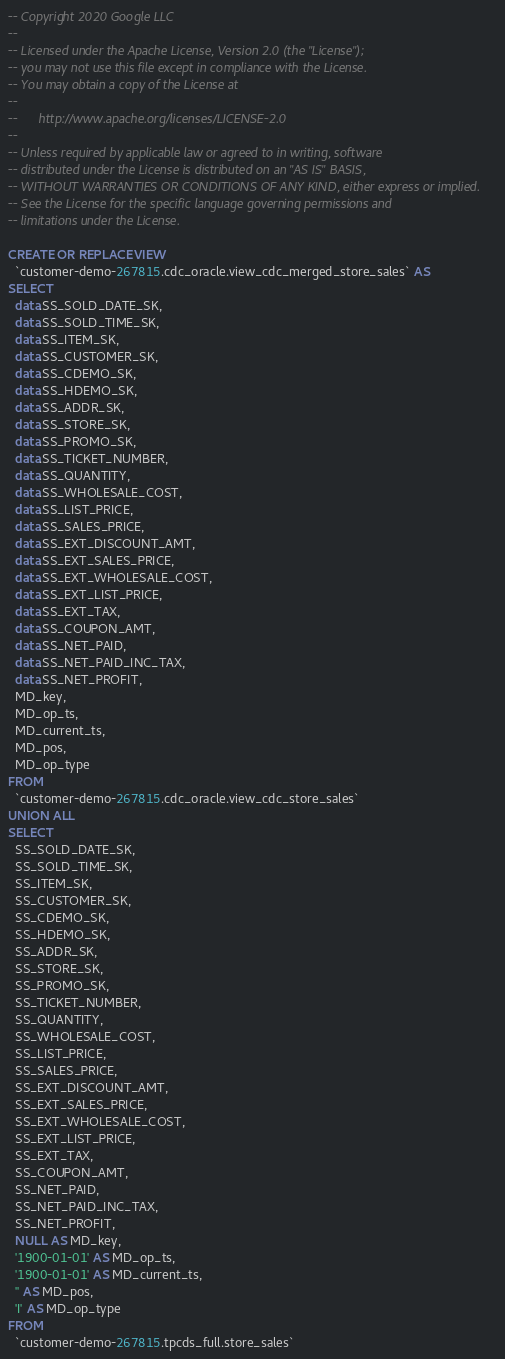<code> <loc_0><loc_0><loc_500><loc_500><_SQL_>-- Copyright 2020 Google LLC
--
-- Licensed under the Apache License, Version 2.0 (the "License");
-- you may not use this file except in compliance with the License.
-- You may obtain a copy of the License at
--
--      http://www.apache.org/licenses/LICENSE-2.0
--
-- Unless required by applicable law or agreed to in writing, software
-- distributed under the License is distributed on an "AS IS" BASIS,
-- WITHOUT WARRANTIES OR CONDITIONS OF ANY KIND, either express or implied.
-- See the License for the specific language governing permissions and
-- limitations under the License.

CREATE OR REPLACE VIEW
  `customer-demo-267815.cdc_oracle.view_cdc_merged_store_sales` AS
SELECT
  data.SS_SOLD_DATE_SK,
  data.SS_SOLD_TIME_SK,
  data.SS_ITEM_SK,
  data.SS_CUSTOMER_SK,
  data.SS_CDEMO_SK,
  data.SS_HDEMO_SK,
  data.SS_ADDR_SK,
  data.SS_STORE_SK,
  data.SS_PROMO_SK,
  data.SS_TICKET_NUMBER,
  data.SS_QUANTITY,
  data.SS_WHOLESALE_COST,
  data.SS_LIST_PRICE,
  data.SS_SALES_PRICE,
  data.SS_EXT_DISCOUNT_AMT,
  data.SS_EXT_SALES_PRICE,
  data.SS_EXT_WHOLESALE_COST,
  data.SS_EXT_LIST_PRICE,
  data.SS_EXT_TAX,
  data.SS_COUPON_AMT,
  data.SS_NET_PAID,
  data.SS_NET_PAID_INC_TAX,
  data.SS_NET_PROFIT,
  MD_key,
  MD_op_ts,
  MD_current_ts,
  MD_pos,
  MD_op_type
FROM
  `customer-demo-267815.cdc_oracle.view_cdc_store_sales`
UNION ALL
SELECT
  SS_SOLD_DATE_SK,
  SS_SOLD_TIME_SK,
  SS_ITEM_SK,
  SS_CUSTOMER_SK,
  SS_CDEMO_SK,
  SS_HDEMO_SK,
  SS_ADDR_SK,
  SS_STORE_SK,
  SS_PROMO_SK,
  SS_TICKET_NUMBER,
  SS_QUANTITY,
  SS_WHOLESALE_COST,
  SS_LIST_PRICE,
  SS_SALES_PRICE,
  SS_EXT_DISCOUNT_AMT,
  SS_EXT_SALES_PRICE,
  SS_EXT_WHOLESALE_COST,
  SS_EXT_LIST_PRICE,
  SS_EXT_TAX,
  SS_COUPON_AMT,
  SS_NET_PAID,
  SS_NET_PAID_INC_TAX,
  SS_NET_PROFIT,
  NULL AS MD_key,
  '1900-01-01' AS MD_op_ts,
  '1900-01-01' AS MD_current_ts,
  '' AS MD_pos,
  'I' AS MD_op_type
FROM
  `customer-demo-267815.tpcds_full.store_sales`</code> 